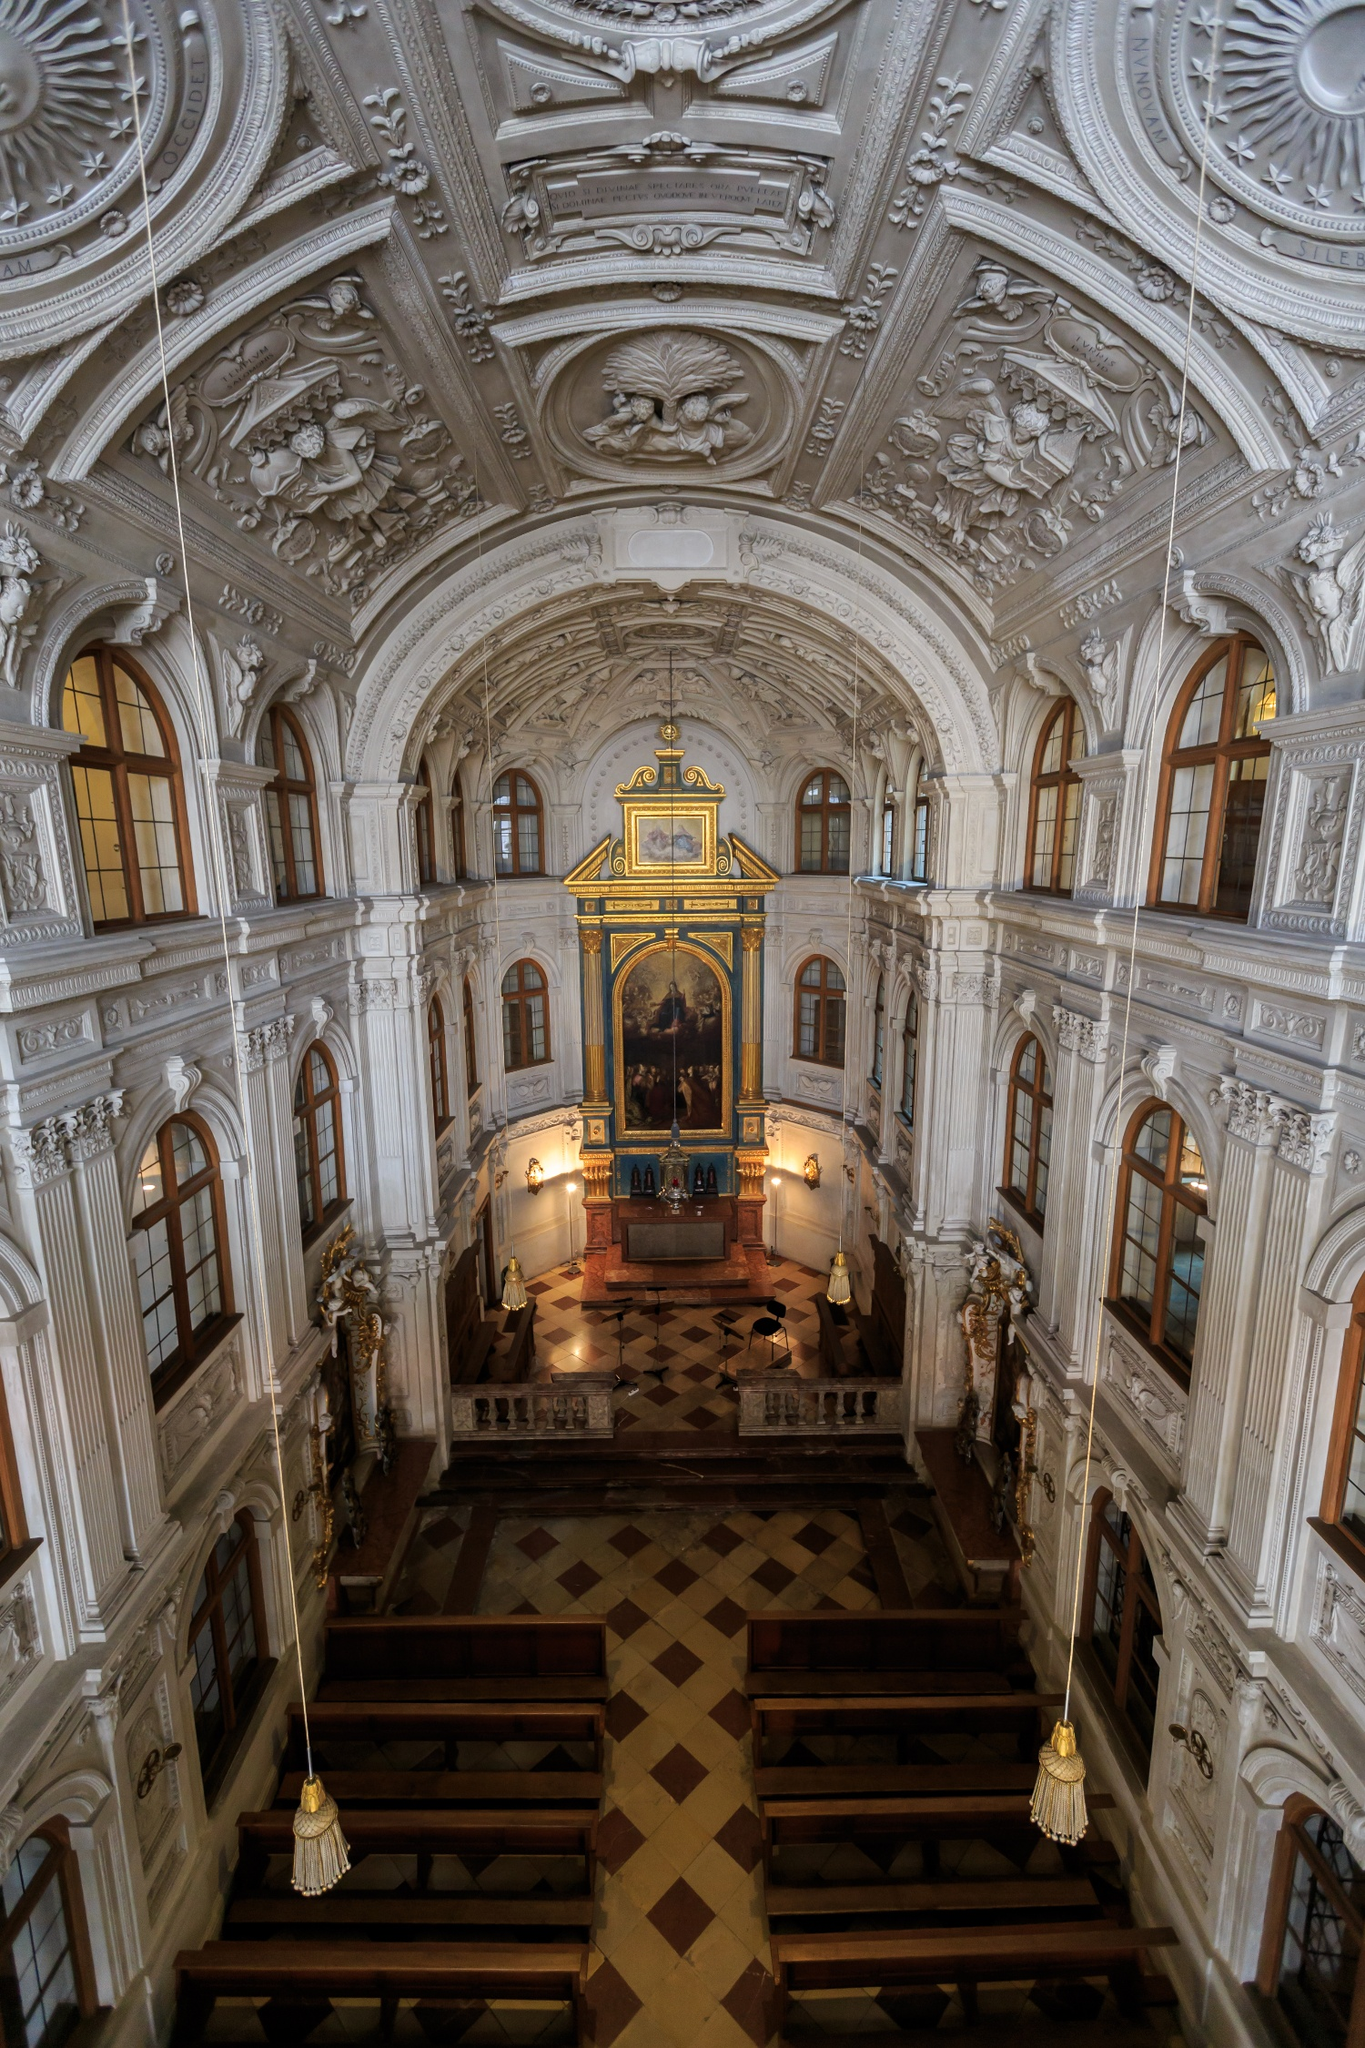Describe an imagined scenario where this church hosts an art gala. In this imagined scenario, the Hofkirche transforms into a breathtaking venue for an exclusive art gala. The church's intricate stucco work and gilded accents provide a grand backdrop for an evening of cultural celebration. Under the soft glow of chandeliers, guests, dressed in elegant attire, explore exhibits of contemporary and classic artworks displayed along the nave. The event opens with a revered art historian sharing insights on the baroque influences that define the church's aesthetic. Music composed by Dresden's finest musicians fills the air, blending harmoniously with the visual splendors. As the night unfolds, attendees enjoy gourmet hors d'oeuvres and fine wines, engaging in conversations about art, history, and the church's timeless significance. 